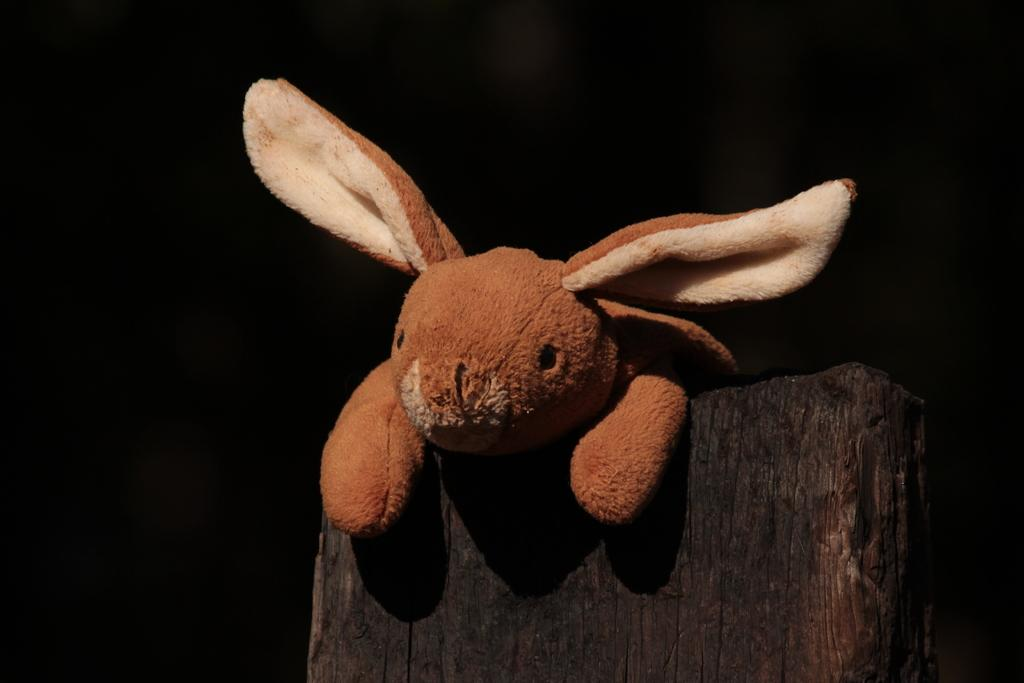What object is present in the image? There is a toy in the image. On what surface is the toy placed? The toy is on a wooden surface. How is the wooden surface depicted in the image? The wooden surface appears to be truncated towards the bottom of the image. What can be observed about the background of the image? The background of the image is dark. Can you see any toes or socks in the image? No, there are no toes or socks present in the image. What type of rice is being cooked in the background of the image? There is no rice visible in the image; it only features a toy on a wooden surface with a dark background. 